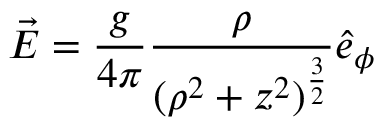Convert formula to latex. <formula><loc_0><loc_0><loc_500><loc_500>\vec { E } = \frac { g } { 4 \pi } \frac { \rho } { ( \rho ^ { 2 } + z ^ { 2 } ) ^ { \frac { 3 } { 2 } } } \hat { e } _ { \phi }</formula> 